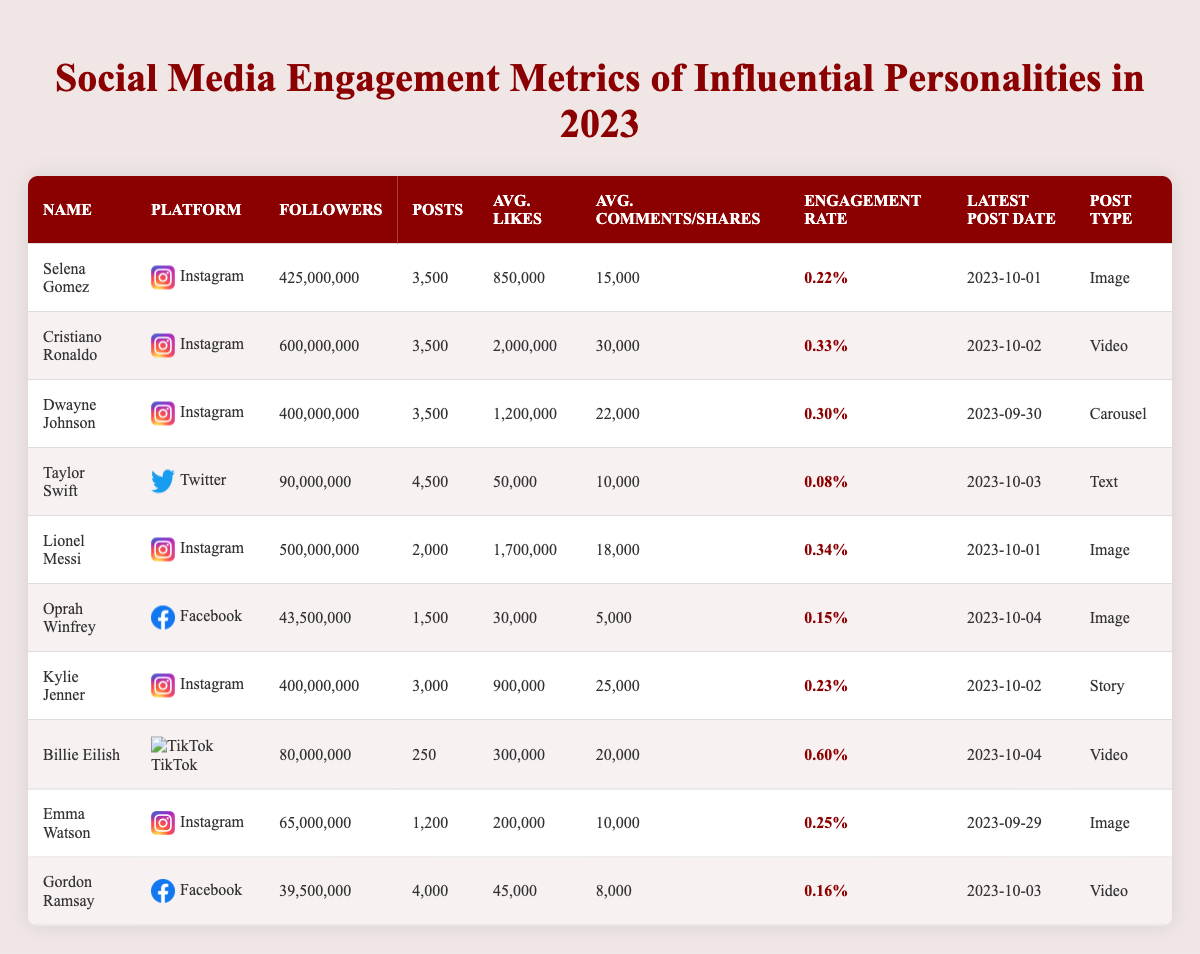What is the highest engagement rate among the personalities listed? Looking at the engagement rates, Billie Eilish has the highest rate at 0.60%. The other personalities have lower engagement rates.
Answer: 0.60% Who has the most followers on Instagram? Cristiano Ronaldo has the highest number of followers on Instagram with 600 million followers.
Answer: 600 million How many posts did Taylor Swift make on Twitter? Taylor Swift made a total of 4,500 posts on Twitter as listed in the table.
Answer: 4,500 What is the average number of likes for posts made by Dwayne Johnson? Dwayne Johnson's average likes per post are reported as 1,200,000, based on the data provided in the table.
Answer: 1,200,000 Which personality has the lowest engagement rate? The lowest engagement rate belongs to Taylor Swift at 0.08%. This can be identified by comparing the rates listed for each personality.
Answer: 0.08% How many total posts do all the Instagram personalities have combined? To find the total, we add the number of posts for Selena Gomez (3,500), Cristiano Ronaldo (3,500), Dwayne Johnson (3,500), Lionel Messi (2,000), Kylie Jenner (3,000), Emma Watson (1,200), and Billie Eilish (250). The sum is 16,450 posts.
Answer: 16,450 Is Lionel Messi's average likes per post greater than 1,500,000? No, Lionel Messi's average likes per post is 1,700,000, which is indeed greater than 1,500,000, as indicated in the table.
Answer: Yes How does the engagement rate of Oprah Winfrey compare to that of Emma Watson? Oprah Winfrey has an engagement rate of 0.15%, while Emma Watson has a higher rate of 0.25%. Therefore, Emma Watson has a better engagement rate compared to Oprah Winfrey.
Answer: Emma Watson has a higher rate What is the total number of average comments collected by Selena Gomez and Kylie Jenner across their posts? Selena Gomez has an average of 15,000 comments per post and Kylie Jenner has 25,000. Thus, the total is 15,000 + 25,000 = 40,000 comments combined.
Answer: 40,000 Which platform has more celebrities listed, Instagram or Facebook? The table shows that Instagram has six personalities (Selena Gomez, Cristiano Ronaldo, Dwayne Johnson, Lionel Messi, Kylie Jenner, and Emma Watson), while Facebook has two (Oprah Winfrey and Gordon Ramsay). Thus, Instagram has more celebrities listed.
Answer: Instagram has more celebrities 